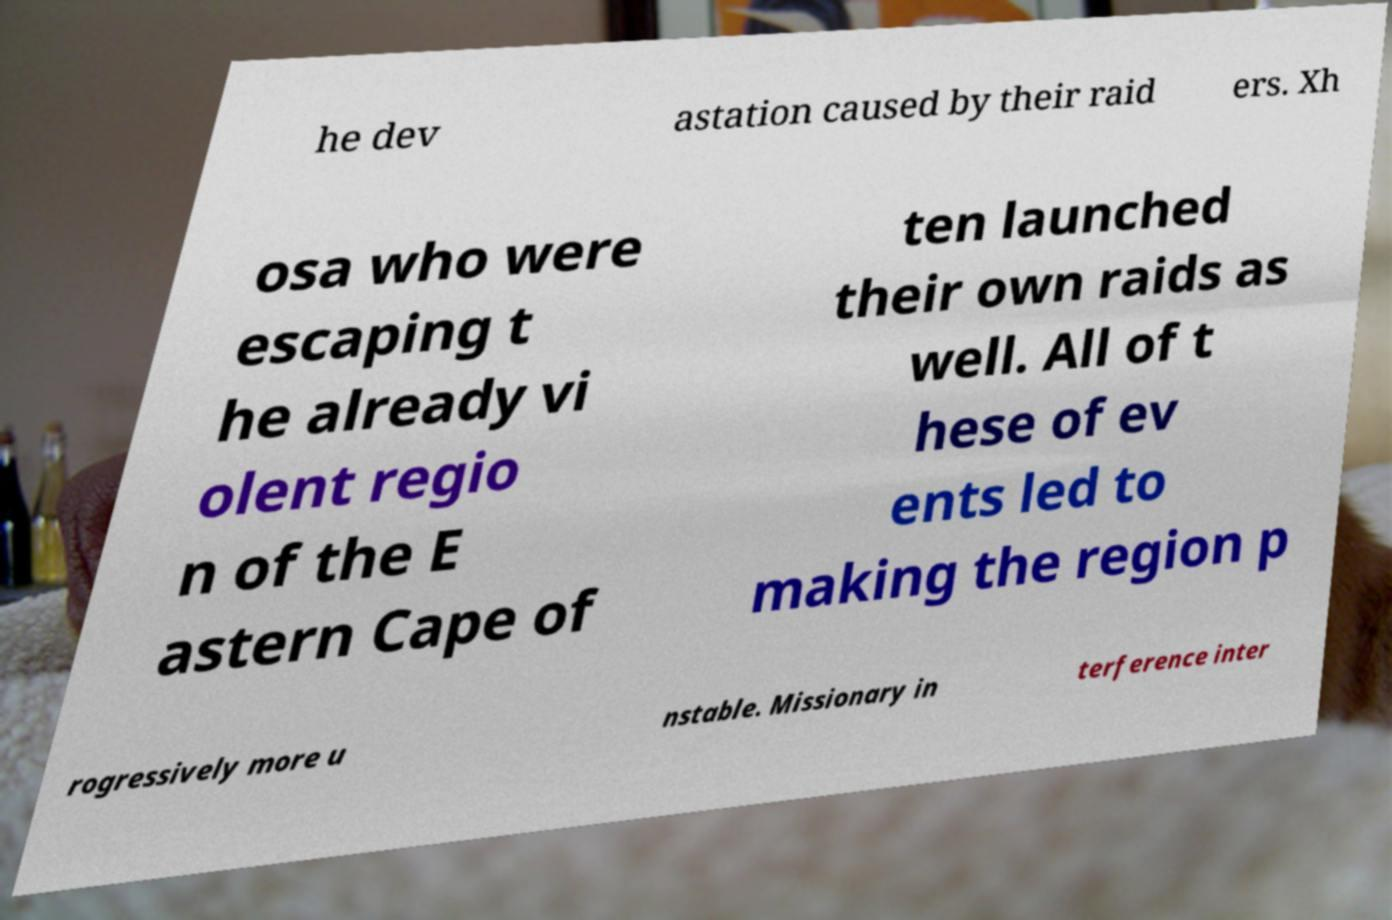Could you assist in decoding the text presented in this image and type it out clearly? he dev astation caused by their raid ers. Xh osa who were escaping t he already vi olent regio n of the E astern Cape of ten launched their own raids as well. All of t hese of ev ents led to making the region p rogressively more u nstable. Missionary in terference inter 